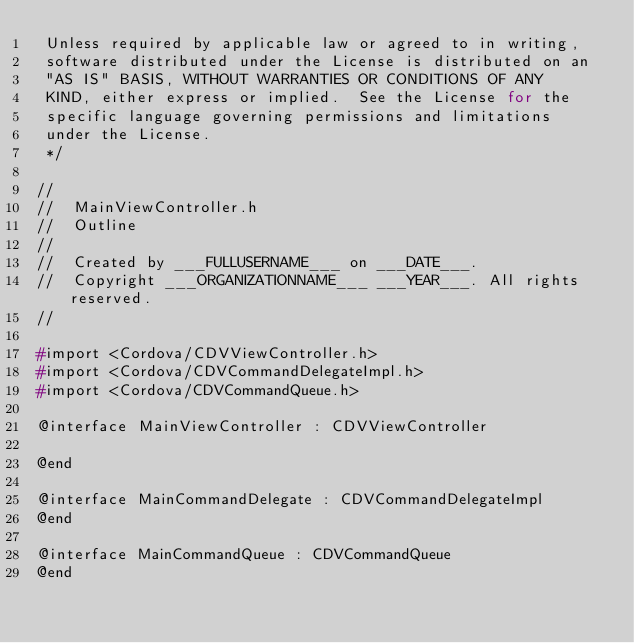Convert code to text. <code><loc_0><loc_0><loc_500><loc_500><_C_> Unless required by applicable law or agreed to in writing,
 software distributed under the License is distributed on an
 "AS IS" BASIS, WITHOUT WARRANTIES OR CONDITIONS OF ANY
 KIND, either express or implied.  See the License for the
 specific language governing permissions and limitations
 under the License.
 */

//
//  MainViewController.h
//  Outline
//
//  Created by ___FULLUSERNAME___ on ___DATE___.
//  Copyright ___ORGANIZATIONNAME___ ___YEAR___. All rights reserved.
//

#import <Cordova/CDVViewController.h>
#import <Cordova/CDVCommandDelegateImpl.h>
#import <Cordova/CDVCommandQueue.h>

@interface MainViewController : CDVViewController

@end

@interface MainCommandDelegate : CDVCommandDelegateImpl
@end

@interface MainCommandQueue : CDVCommandQueue
@end
</code> 